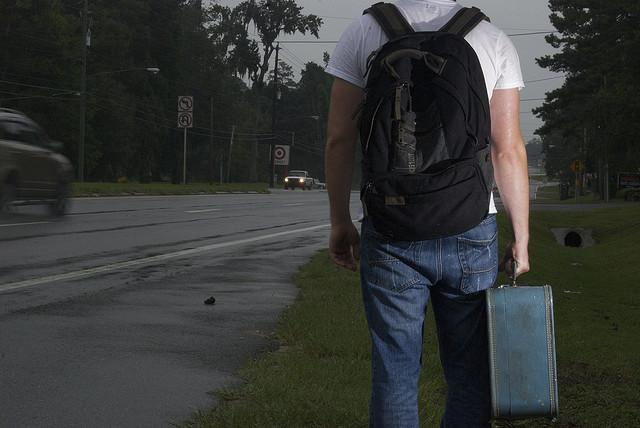What does the backpacking man hope for?

Choices:
A) ride
B) nothing
C) dinner
D) motor bike ride 